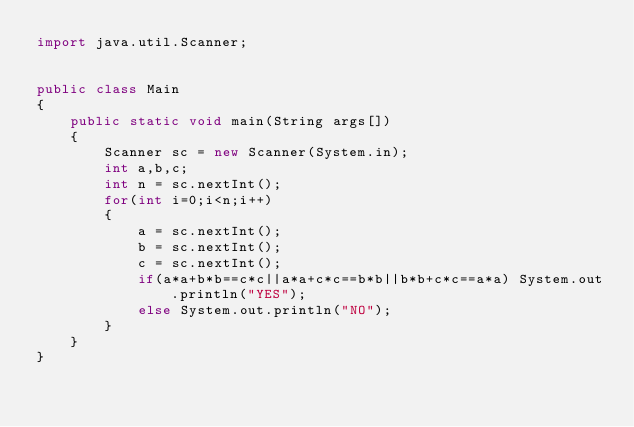Convert code to text. <code><loc_0><loc_0><loc_500><loc_500><_Java_>import java.util.Scanner;


public class Main
{
	public static void main(String args[])
	{
		Scanner sc = new Scanner(System.in);
		int a,b,c;
		int n = sc.nextInt();
		for(int i=0;i<n;i++)
		{
			a = sc.nextInt();
			b = sc.nextInt();
			c = sc.nextInt();
			if(a*a+b*b==c*c||a*a+c*c==b*b||b*b+c*c==a*a) System.out.println("YES");
			else System.out.println("NO");
		}
	}
}</code> 